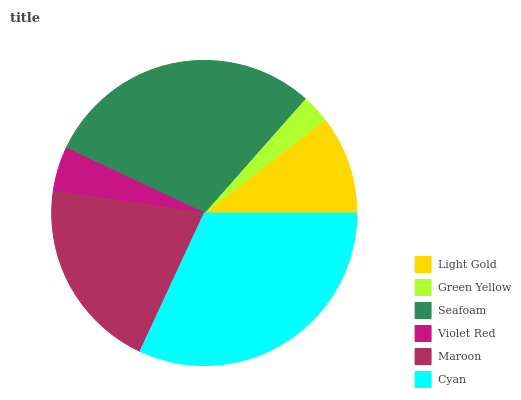Is Green Yellow the minimum?
Answer yes or no. Yes. Is Cyan the maximum?
Answer yes or no. Yes. Is Seafoam the minimum?
Answer yes or no. No. Is Seafoam the maximum?
Answer yes or no. No. Is Seafoam greater than Green Yellow?
Answer yes or no. Yes. Is Green Yellow less than Seafoam?
Answer yes or no. Yes. Is Green Yellow greater than Seafoam?
Answer yes or no. No. Is Seafoam less than Green Yellow?
Answer yes or no. No. Is Maroon the high median?
Answer yes or no. Yes. Is Light Gold the low median?
Answer yes or no. Yes. Is Violet Red the high median?
Answer yes or no. No. Is Cyan the low median?
Answer yes or no. No. 